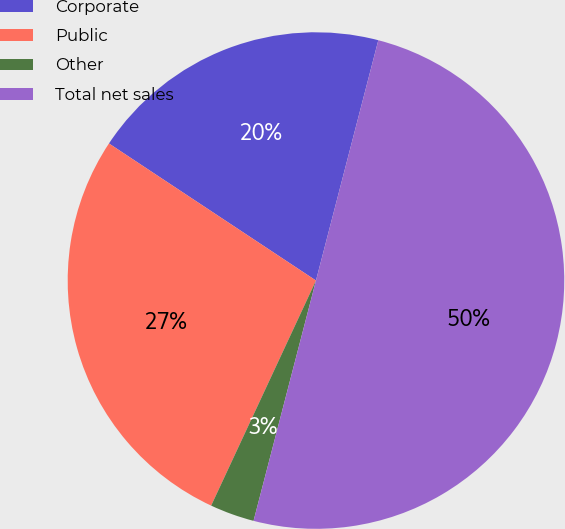Convert chart to OTSL. <chart><loc_0><loc_0><loc_500><loc_500><pie_chart><fcel>Corporate<fcel>Public<fcel>Other<fcel>Total net sales<nl><fcel>19.73%<fcel>27.37%<fcel>2.89%<fcel>50.0%<nl></chart> 